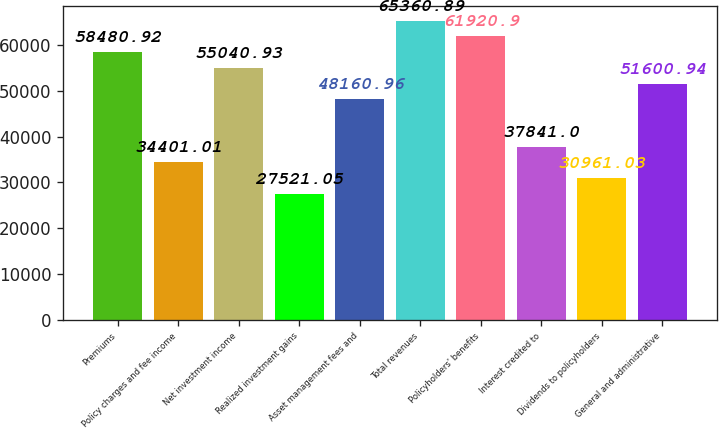<chart> <loc_0><loc_0><loc_500><loc_500><bar_chart><fcel>Premiums<fcel>Policy charges and fee income<fcel>Net investment income<fcel>Realized investment gains<fcel>Asset management fees and<fcel>Total revenues<fcel>Policyholders' benefits<fcel>Interest credited to<fcel>Dividends to policyholders<fcel>General and administrative<nl><fcel>58480.9<fcel>34401<fcel>55040.9<fcel>27521<fcel>48161<fcel>65360.9<fcel>61920.9<fcel>37841<fcel>30961<fcel>51600.9<nl></chart> 